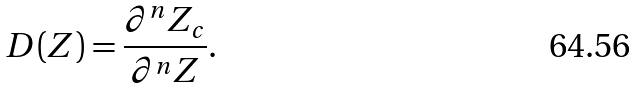<formula> <loc_0><loc_0><loc_500><loc_500>D ( Z ) = \frac { \partial ^ { n } Z _ { c } } { \partial ^ { n } Z } .</formula> 